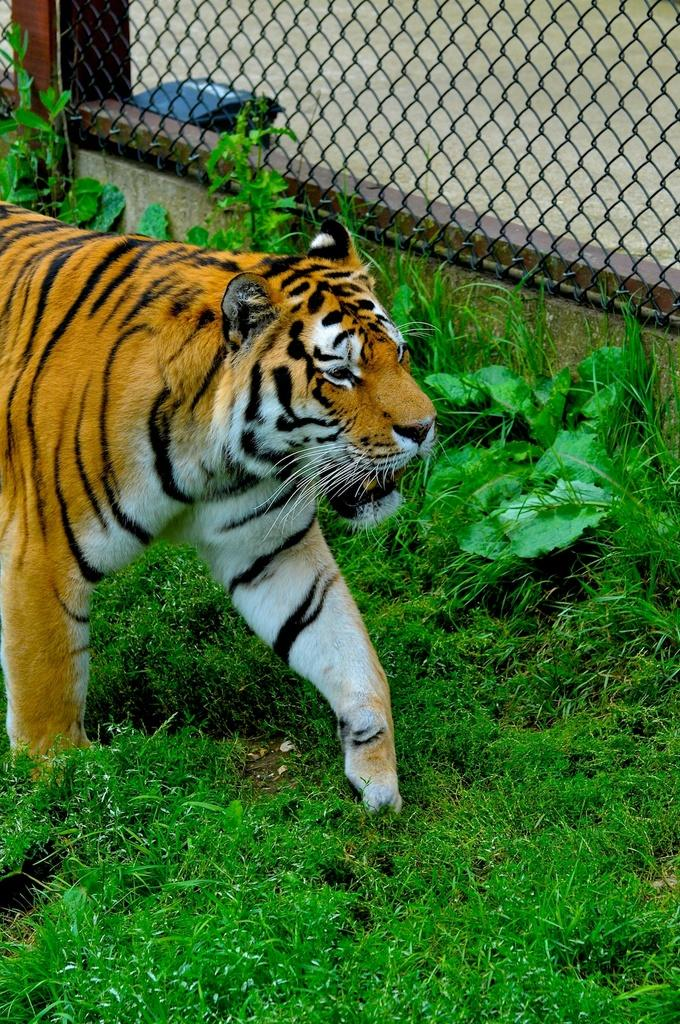What animal is the main subject of the image? There is a tiger in the image. What is the tiger standing on? The tiger is on the grass floor. What is located near the tiger? There is fencing to the side of the tiger. What type of vegetation is present in the image? There are plants around the tiger. What type of notebook is the tiger using to write in the image? There is no notebook present in the image, and the tiger is not shown writing. 